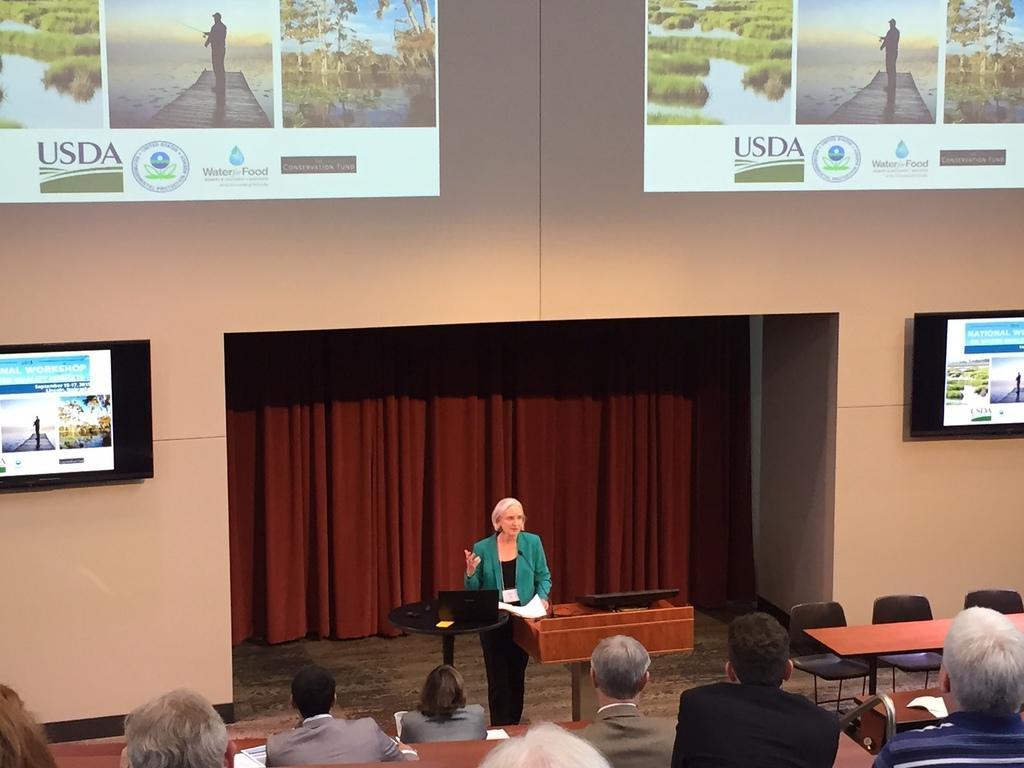Describe this image in one or two sentences. In this image i can see few persons sitting at the back ground i can see a man standing a chair, a bench, a wall,a screen and a curtain. 